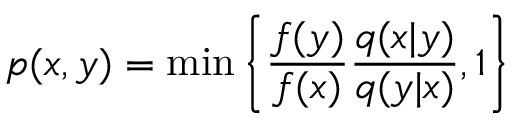<formula> <loc_0><loc_0><loc_500><loc_500>p ( x , y ) = \min \left \{ \frac { f ( y ) } { f ( x ) } \frac { q ( x | y ) } { q ( y | x ) } , 1 \right \}</formula> 